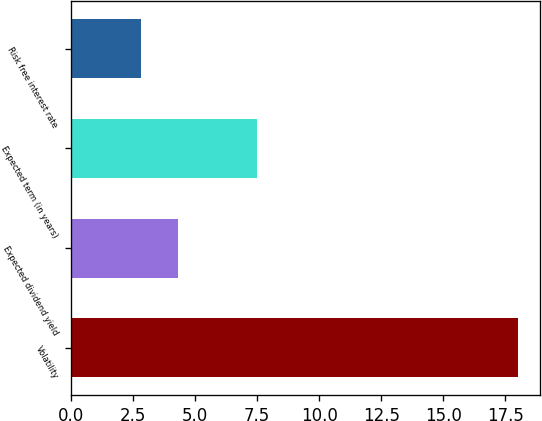<chart> <loc_0><loc_0><loc_500><loc_500><bar_chart><fcel>Volatility<fcel>Expected dividend yield<fcel>Expected term (in years)<fcel>Risk free interest rate<nl><fcel>18<fcel>4.32<fcel>7.5<fcel>2.8<nl></chart> 